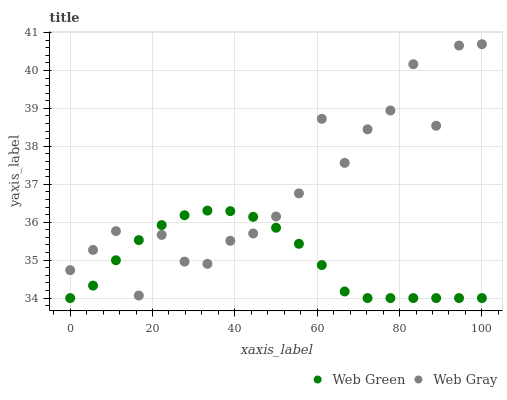Does Web Green have the minimum area under the curve?
Answer yes or no. Yes. Does Web Gray have the maximum area under the curve?
Answer yes or no. Yes. Does Web Green have the maximum area under the curve?
Answer yes or no. No. Is Web Green the smoothest?
Answer yes or no. Yes. Is Web Gray the roughest?
Answer yes or no. Yes. Is Web Green the roughest?
Answer yes or no. No. Does Web Green have the lowest value?
Answer yes or no. Yes. Does Web Gray have the highest value?
Answer yes or no. Yes. Does Web Green have the highest value?
Answer yes or no. No. Does Web Green intersect Web Gray?
Answer yes or no. Yes. Is Web Green less than Web Gray?
Answer yes or no. No. Is Web Green greater than Web Gray?
Answer yes or no. No. 